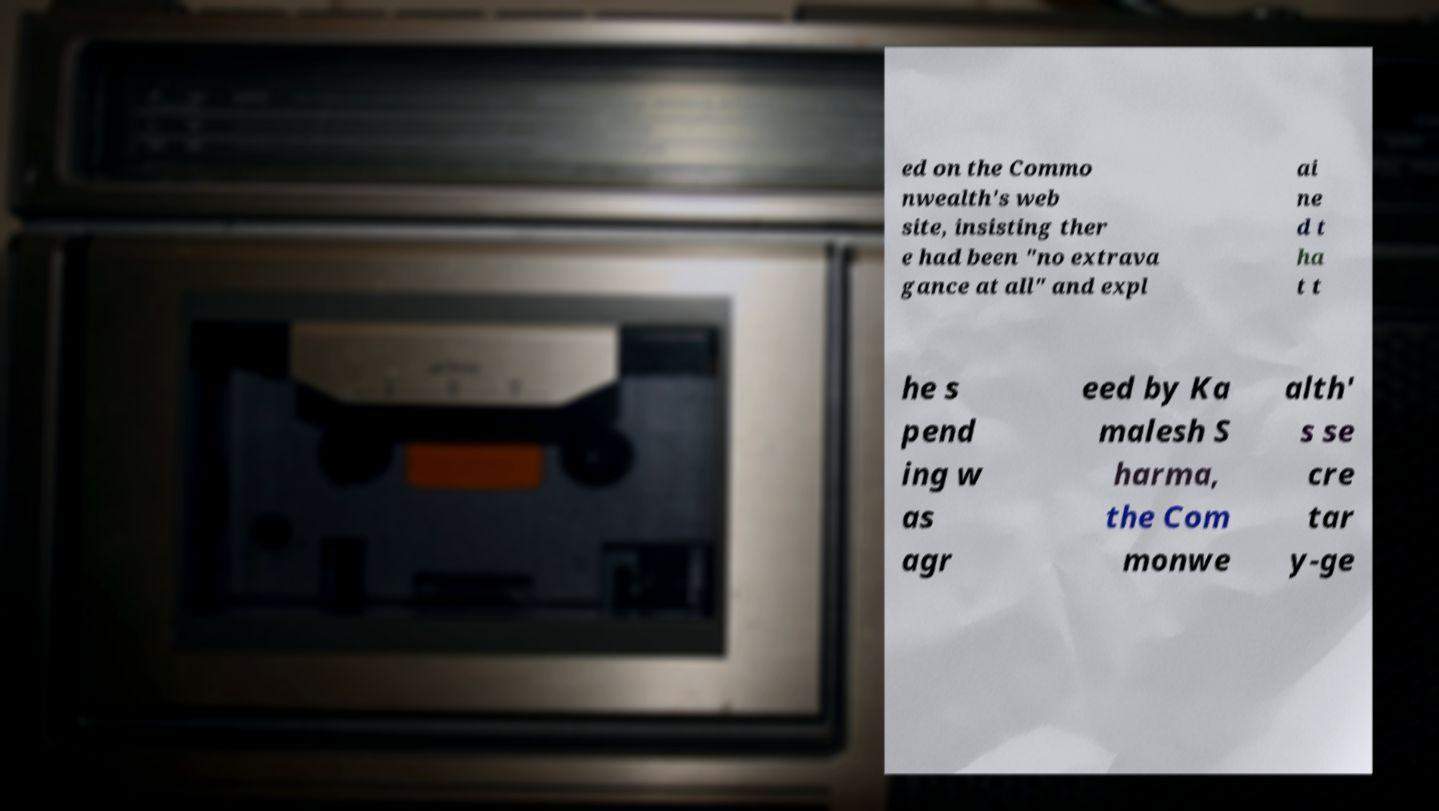There's text embedded in this image that I need extracted. Can you transcribe it verbatim? ed on the Commo nwealth's web site, insisting ther e had been "no extrava gance at all" and expl ai ne d t ha t t he s pend ing w as agr eed by Ka malesh S harma, the Com monwe alth' s se cre tar y-ge 